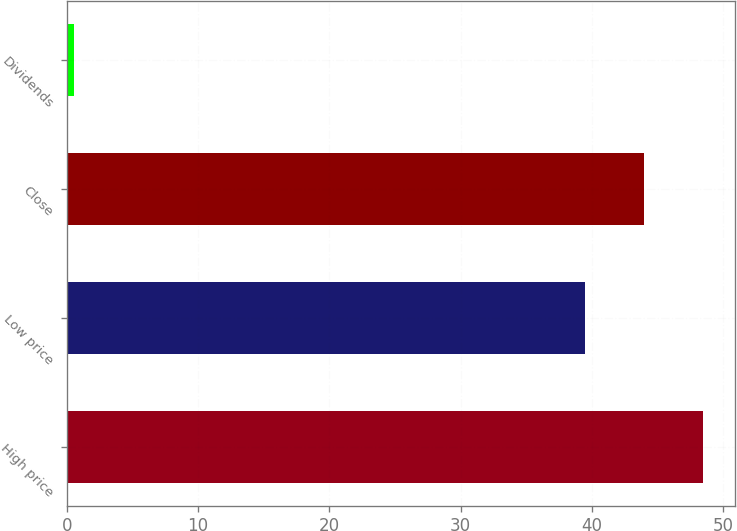Convert chart to OTSL. <chart><loc_0><loc_0><loc_500><loc_500><bar_chart><fcel>High price<fcel>Low price<fcel>Close<fcel>Dividends<nl><fcel>48.45<fcel>39.51<fcel>43.98<fcel>0.53<nl></chart> 